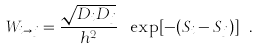<formula> <loc_0><loc_0><loc_500><loc_500>W _ { i \rightarrow j } = \frac { \sqrt { D _ { i } D _ { j } } } { h ^ { 2 } } \ \exp [ - ( S _ { i } - S _ { j } ) ] \ .</formula> 